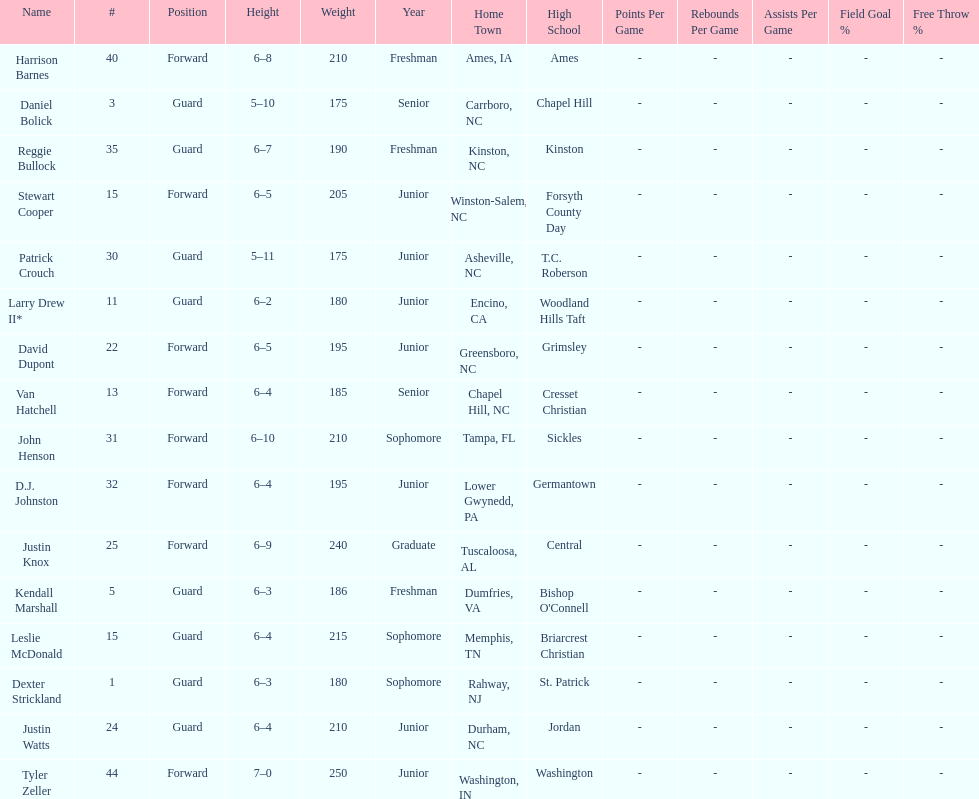Parse the table in full. {'header': ['Name', '#', 'Position', 'Height', 'Weight', 'Year', 'Home Town', 'High School', 'Points Per Game', 'Rebounds Per Game', 'Assists Per Game', 'Field Goal %', 'Free Throw %'], 'rows': [['Harrison Barnes', '40', 'Forward', '6–8', '210', 'Freshman', 'Ames, IA', 'Ames', '-', '-', '-', '-', '-'], ['Daniel Bolick', '3', 'Guard', '5–10', '175', 'Senior', 'Carrboro, NC', 'Chapel Hill', '-', '-', '-', '-', '-'], ['Reggie Bullock', '35', 'Guard', '6–7', '190', 'Freshman', 'Kinston, NC', 'Kinston', '-', '-', '-', '-', '-'], ['Stewart Cooper', '15', 'Forward', '6–5', '205', 'Junior', 'Winston-Salem, NC', 'Forsyth County Day', '-', '-', '-', '-', '-'], ['Patrick Crouch', '30', 'Guard', '5–11', '175', 'Junior', 'Asheville, NC', 'T.C. Roberson', '-', '-', '-', '-', '-'], ['Larry Drew II*', '11', 'Guard', '6–2', '180', 'Junior', 'Encino, CA', 'Woodland Hills Taft', '-', '-', '-', '-', '-'], ['David Dupont', '22', 'Forward', '6–5', '195', 'Junior', 'Greensboro, NC', 'Grimsley', '-', '-', '-', '-', '-'], ['Van Hatchell', '13', 'Forward', '6–4', '185', 'Senior', 'Chapel Hill, NC', 'Cresset Christian', '-', '-', '-', '-', '-'], ['John Henson', '31', 'Forward', '6–10', '210', 'Sophomore', 'Tampa, FL', 'Sickles', '-', '-', '-', '-', '-'], ['D.J. Johnston', '32', 'Forward', '6–4', '195', 'Junior', 'Lower Gwynedd, PA', 'Germantown', '-', '-', '-', '-', '-'], ['Justin Knox', '25', 'Forward', '6–9', '240', 'Graduate', 'Tuscaloosa, AL', 'Central', '-', '-', '-', '-', '-'], ['Kendall Marshall', '5', 'Guard', '6–3', '186', 'Freshman', 'Dumfries, VA', "Bishop O'Connell", '-', '-', '-', '-', '-'], ['Leslie McDonald', '15', 'Guard', '6–4', '215', 'Sophomore', 'Memphis, TN', 'Briarcrest Christian', '-', '-', '-', '-', '-'], ['Dexter Strickland', '1', 'Guard', '6–3', '180', 'Sophomore', 'Rahway, NJ', 'St. Patrick', '-', '-', '-', '-', '-'], ['Justin Watts', '24', 'Guard', '6–4', '210', 'Junior', 'Durham, NC', 'Jordan', '-', '-', '-', '-', '-'], ['Tyler Zeller', '44', 'Forward', '7–0', '250', 'Junior', 'Washington, IN', 'Washington', '-', '-', '-', '-', '-']]} What is the number of players with a weight over 200? 7. 